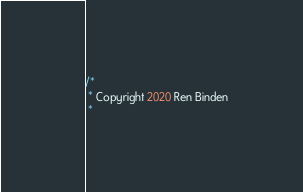Convert code to text. <code><loc_0><loc_0><loc_500><loc_500><_Kotlin_>/*
 * Copyright 2020 Ren Binden
 *</code> 